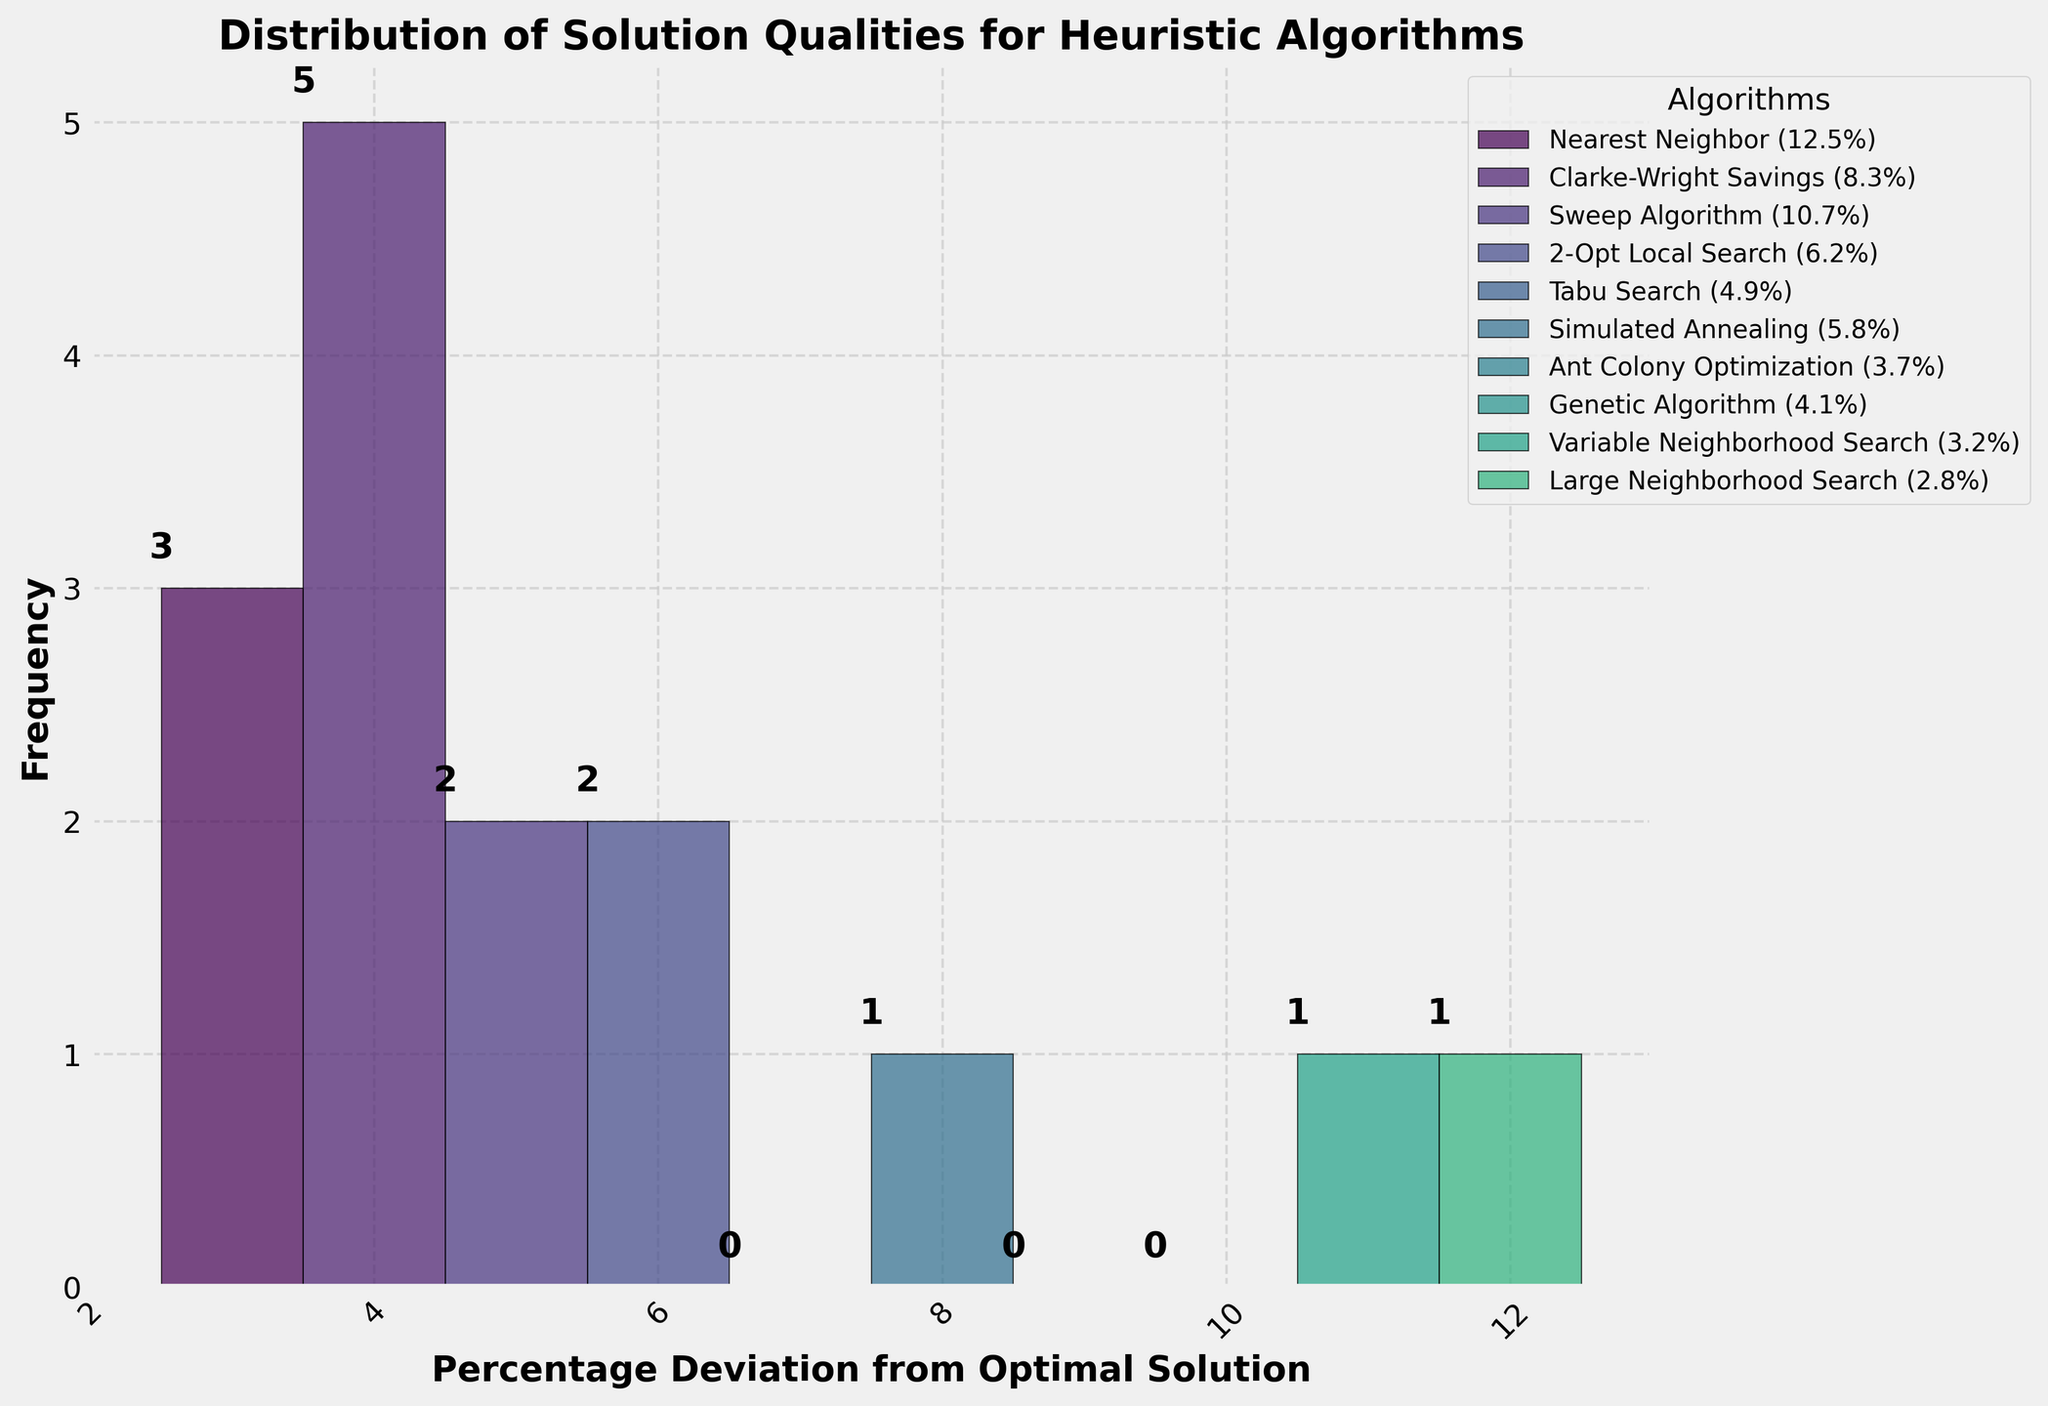What is the title of the figure? The title of a figure is usually at the top, in a larger or bold font, summarizing the content. In this case, you can see the title as 'Distribution of Solution Qualities for Heuristic Algorithms'.
Answer: Distribution of Solution Qualities for Heuristic Algorithms What do the x-axis and y-axis represent? The x-axis label is 'Percentage Deviation from Optimal Solution', which indicates the measurement of deviation from known optimal solutions. The y-axis label is 'Frequency' which tells us how often each range of deviations occurs.
Answer: Percentage Deviation from Optimal Solution; Frequency How many bins are used in the histogram? Count the number of distinct vertical bars (bins) in the histogram. Each bin represents a range of values for the percentage deviation.
Answer: 10 Which algorithm(s) have the smallest percentage deviation? Look for the algorithms that are located in the bins with the smallest deviation values, close to the origin of the x-axis. From the legend, identify the algorithm(s) within those bins.
Answer: Adaptive Large Neighborhood Search Which algorithm(s) have the largest percentage deviation? Focus on the rightmost bin(s) with the highest x-axis values for the percentage deviation and identify the algorithms listed in the legend corresponding to these bins.
Answer: Nearest Neighbor What is the frequency of the bin containing the algorithm with the smallest percentage deviation? Locate the bin for the smallest percentage deviation. The frequency is the height of that bin, which can also be confirmed by the value written above the bin.
Answer: 1 Which bin has the highest frequency and what is its value? Identify the tallest bin by comparing the heights of all bins, and read the frequency value above it.
Answer: The bin containing Adaptive Large Neighborhood Search, Clarke-Wright Savings, Simulated Annealing, Tabu Search, and two others; 3 How does the performance of the Genetic Algorithm compare to the Particle Swarm Optimization? Find the bins where Genetic Algorithm (4.1%) and Particle Swarm Optimization (5.1%) are located, and compare their heights, indicating their frequencies.
Answer: Genetic Algorithm (lower deviation) is in a lower bin, indicating slightly better performance What is the average percentage deviation for the algorithms? Add all the percentage deviation values and divide by the number of algorithms. (12.5 + 8.3 + 10.7 + 6.2 + 4.9 + 5.8 + 3.7 + 4.1 + 3.2 + 2.8 + 3.5 + 4.3 + 5.1 + 3.9 + 2.5) / 15 = 5.42
Answer: 5.42 What can you infer about the distribution of these solution qualities? Examine the shape of the histogram, the spread of bars across the bins, and the central tendency. It generally slopes towards the left, indicating more algorithms achieve lower deviations from the optimal solution.
Answer: More algorithms have lower percentage deviations, indicating higher solution quality 